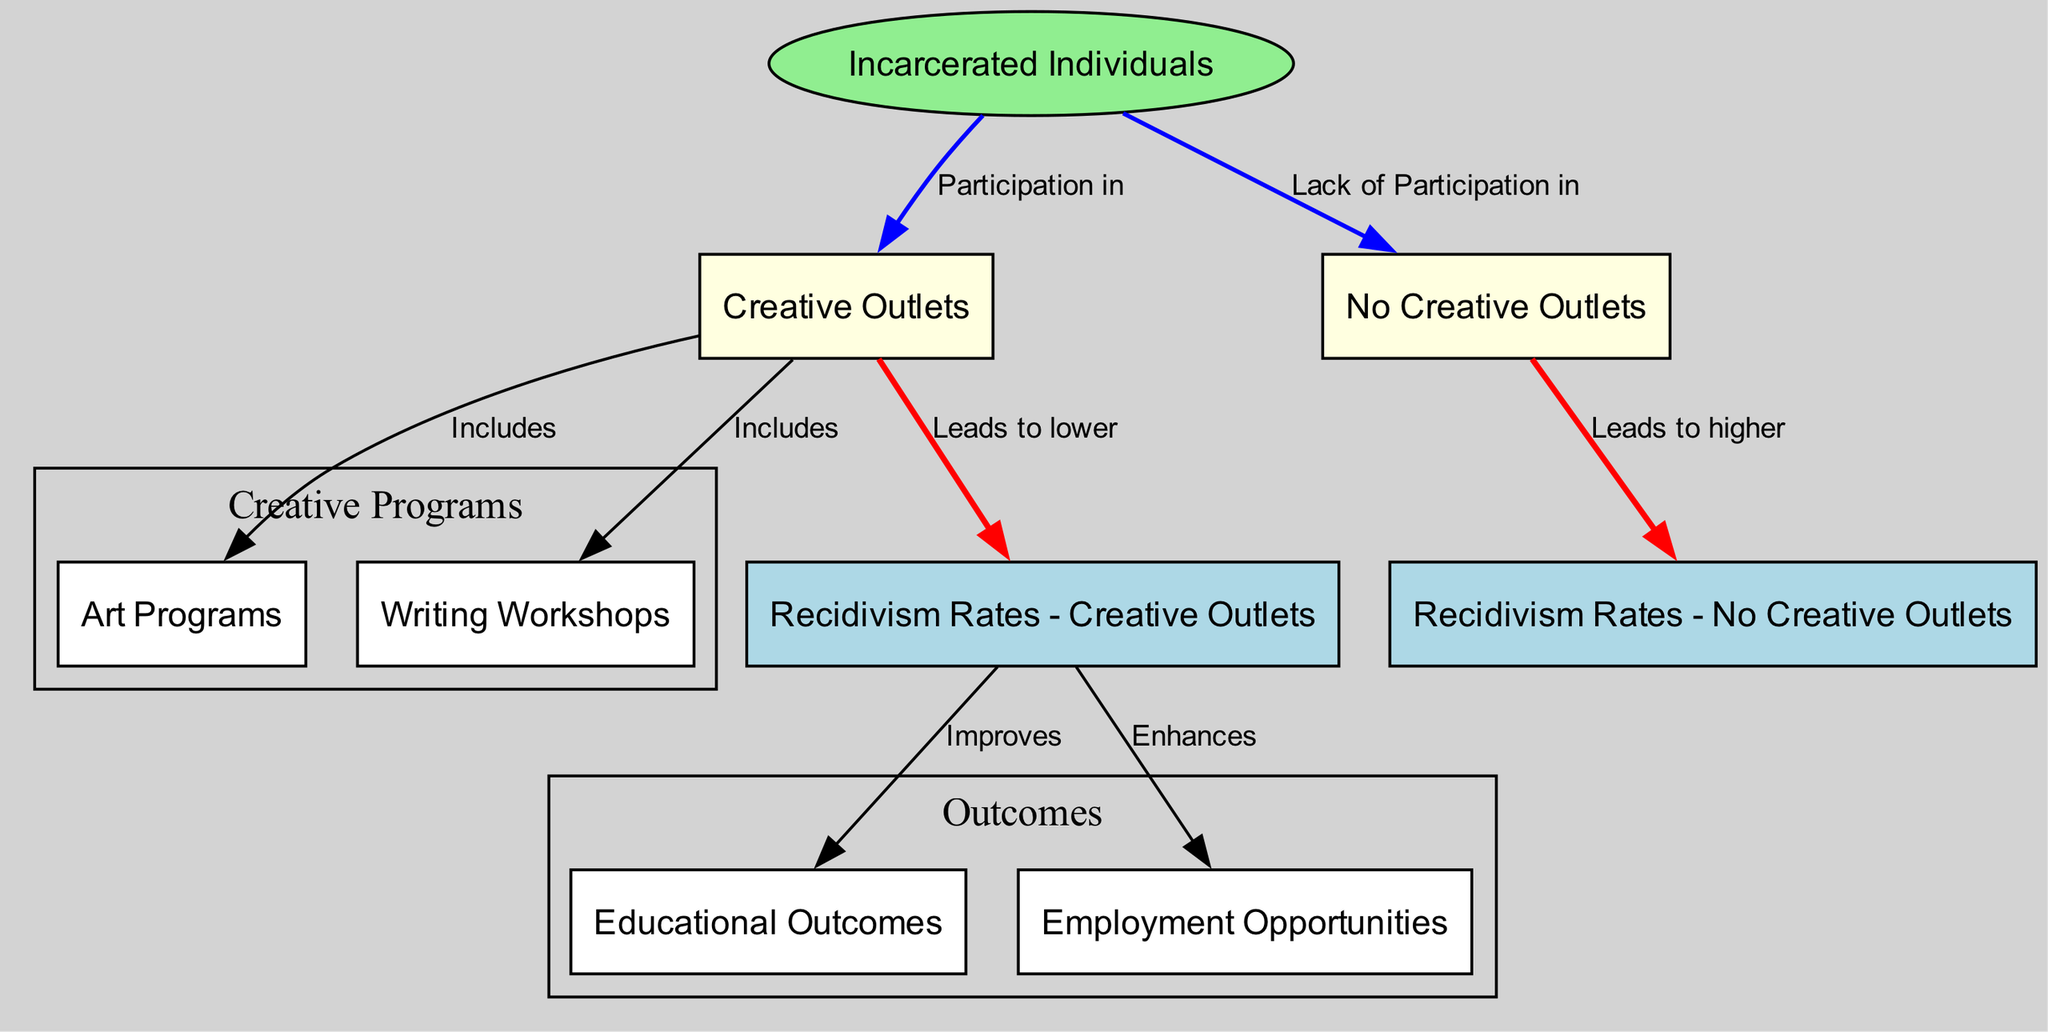What are the two main categories of participation for incarcerated individuals in the diagram? The diagram indicates two main categories related to participation: 'Creative Outlets' and 'No Creative Outlets'. This is evident in the two distinct nodes stemming from the 'Incarcerated Individuals' node.
Answer: Creative Outlets, No Creative Outlets Which creative outlets are mentioned in the diagram? The diagram specifies two creative outlets under the 'Creative Outlets' node: 'Art Programs' and 'Writing Workshops'. Both of these are listed as part of the creative outlets included in the engagement of incarcerated individuals.
Answer: Art Programs, Writing Workshops What is the relationship between creative outlets and recidivism rates? The diagram illustrates that participation in 'Creative Outlets' leads to lower 'Recidivism Rates - Creative Outlets'. This connection is shown by an edge that indicates the positive impact of creative activities on reoffending rates.
Answer: Leads to lower How many educational outcomes are improved due to lower recidivism rates in the diagram? The 'Recidivism Rates - Creative Outlets' node is connected to two outcomes: 'Educational Outcomes' and 'Employment Opportunities'. Each connection implies an improvement, leading to a count of two educational outcomes.
Answer: 2 What does participation in creative outlets lead to in terms of recidivism rates compared to lack of participation? The diagram shows that participation in creative outlets leads to lower recidivism rates, while lack of participation in creative outlets leads to higher recidivism rates. This comparative analysis highlights the negative impact of not engaging in creative activities.
Answer: Lower, Higher What colors are used to differentiate the nodes in the diagram? The nodes in the diagram are assigned specific colors to represent their types: 'Incarcerated Individuals' is light green (ellipse), 'Creative Outlets' and 'No Creative Outlets' are light yellow, and 'Recidivism Rates' nodes are light blue. These colors help visually categorize the different elements.
Answer: Light green, light yellow, light blue How does lower recidivism rates impact employment opportunities according to the diagram? The diagram indicates that lower 'Recidivism Rates - Creative Outlets' enhances 'Employment Opportunities'. This relationship is highlighted by an edge leading from lower recidivism rates to the employment opportunities node, showing a positive effect.
Answer: Enhances If no creative outlets are present, what is the effect on recidivism rates? The relationship illustrated in the diagram shows that the absence of creative outlets results in higher 'Recidivism Rates - No Creative Outlets'. The edge indicates a negative effect associated with the lack of creative engagement.
Answer: Higher What kind of diagram is depicted in this data representation? The diagram highlights a comparative analysis of reoffending rates concerning creative outlets versus no creative outlets, focusing on social science perspectives on incarceration and rehabilitation. This type indicates a comparative and causal relationship between variables.
Answer: Comparative Analysis of Reoffending Rates 